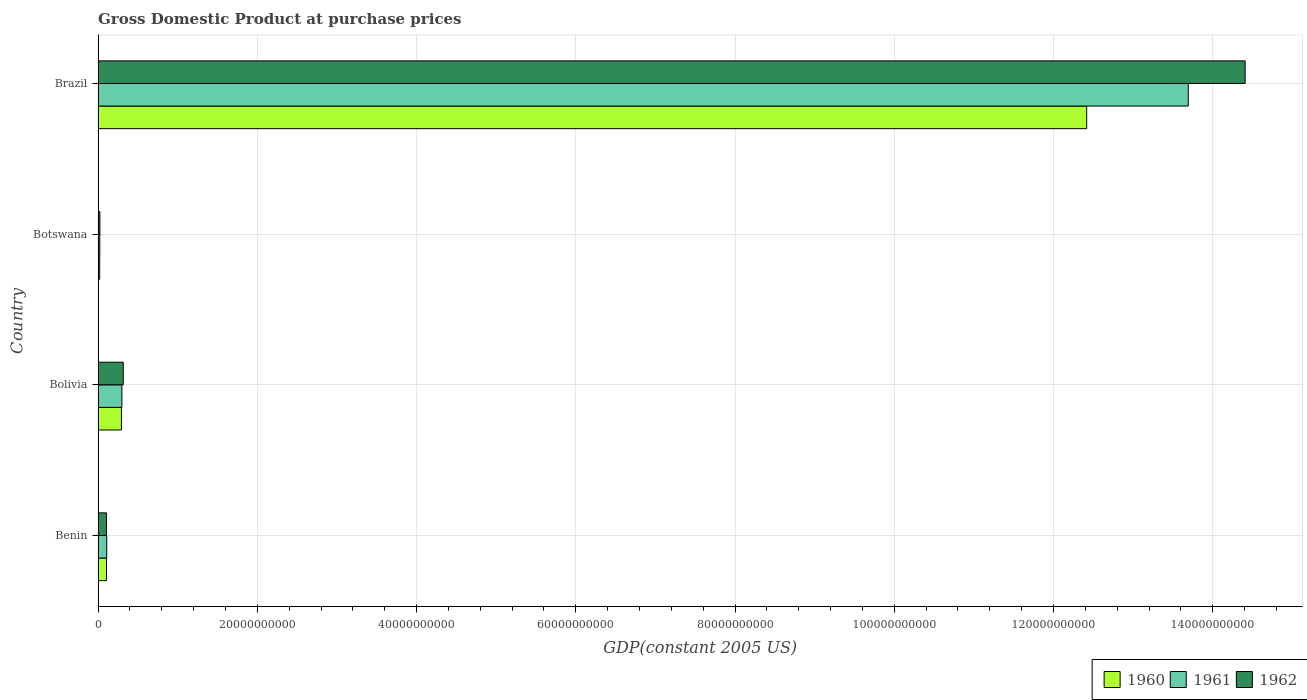How many different coloured bars are there?
Ensure brevity in your answer.  3. How many bars are there on the 1st tick from the top?
Keep it short and to the point. 3. How many bars are there on the 1st tick from the bottom?
Give a very brief answer. 3. What is the label of the 4th group of bars from the top?
Your response must be concise. Benin. What is the GDP at purchase prices in 1961 in Bolivia?
Provide a succinct answer. 2.99e+09. Across all countries, what is the maximum GDP at purchase prices in 1960?
Offer a terse response. 1.24e+11. Across all countries, what is the minimum GDP at purchase prices in 1961?
Your response must be concise. 2.12e+08. In which country was the GDP at purchase prices in 1962 maximum?
Ensure brevity in your answer.  Brazil. In which country was the GDP at purchase prices in 1961 minimum?
Offer a very short reply. Botswana. What is the total GDP at purchase prices in 1962 in the graph?
Offer a terse response. 1.48e+11. What is the difference between the GDP at purchase prices in 1960 in Bolivia and that in Botswana?
Give a very brief answer. 2.73e+09. What is the difference between the GDP at purchase prices in 1962 in Benin and the GDP at purchase prices in 1961 in Brazil?
Your answer should be compact. -1.36e+11. What is the average GDP at purchase prices in 1960 per country?
Provide a succinct answer. 3.21e+1. What is the difference between the GDP at purchase prices in 1960 and GDP at purchase prices in 1961 in Brazil?
Provide a succinct answer. -1.28e+1. In how many countries, is the GDP at purchase prices in 1960 greater than 80000000000 US$?
Provide a succinct answer. 1. What is the ratio of the GDP at purchase prices in 1960 in Benin to that in Botswana?
Your response must be concise. 5.29. Is the GDP at purchase prices in 1961 in Benin less than that in Botswana?
Ensure brevity in your answer.  No. Is the difference between the GDP at purchase prices in 1960 in Bolivia and Brazil greater than the difference between the GDP at purchase prices in 1961 in Bolivia and Brazil?
Keep it short and to the point. Yes. What is the difference between the highest and the second highest GDP at purchase prices in 1962?
Provide a short and direct response. 1.41e+11. What is the difference between the highest and the lowest GDP at purchase prices in 1960?
Offer a very short reply. 1.24e+11. Is it the case that in every country, the sum of the GDP at purchase prices in 1961 and GDP at purchase prices in 1962 is greater than the GDP at purchase prices in 1960?
Your response must be concise. Yes. What is the difference between two consecutive major ticks on the X-axis?
Your answer should be compact. 2.00e+1. Are the values on the major ticks of X-axis written in scientific E-notation?
Ensure brevity in your answer.  No. Does the graph contain grids?
Provide a short and direct response. Yes. How many legend labels are there?
Give a very brief answer. 3. What is the title of the graph?
Your answer should be compact. Gross Domestic Product at purchase prices. What is the label or title of the X-axis?
Provide a succinct answer. GDP(constant 2005 US). What is the label or title of the Y-axis?
Keep it short and to the point. Country. What is the GDP(constant 2005 US) of 1960 in Benin?
Offer a terse response. 1.05e+09. What is the GDP(constant 2005 US) of 1961 in Benin?
Offer a terse response. 1.09e+09. What is the GDP(constant 2005 US) of 1962 in Benin?
Keep it short and to the point. 1.05e+09. What is the GDP(constant 2005 US) of 1960 in Bolivia?
Offer a terse response. 2.93e+09. What is the GDP(constant 2005 US) of 1961 in Bolivia?
Your answer should be very brief. 2.99e+09. What is the GDP(constant 2005 US) in 1962 in Bolivia?
Give a very brief answer. 3.16e+09. What is the GDP(constant 2005 US) of 1960 in Botswana?
Give a very brief answer. 1.99e+08. What is the GDP(constant 2005 US) of 1961 in Botswana?
Your response must be concise. 2.12e+08. What is the GDP(constant 2005 US) in 1962 in Botswana?
Your response must be concise. 2.26e+08. What is the GDP(constant 2005 US) of 1960 in Brazil?
Offer a terse response. 1.24e+11. What is the GDP(constant 2005 US) of 1961 in Brazil?
Your response must be concise. 1.37e+11. What is the GDP(constant 2005 US) in 1962 in Brazil?
Offer a very short reply. 1.44e+11. Across all countries, what is the maximum GDP(constant 2005 US) in 1960?
Ensure brevity in your answer.  1.24e+11. Across all countries, what is the maximum GDP(constant 2005 US) of 1961?
Your response must be concise. 1.37e+11. Across all countries, what is the maximum GDP(constant 2005 US) in 1962?
Provide a short and direct response. 1.44e+11. Across all countries, what is the minimum GDP(constant 2005 US) of 1960?
Provide a succinct answer. 1.99e+08. Across all countries, what is the minimum GDP(constant 2005 US) in 1961?
Keep it short and to the point. 2.12e+08. Across all countries, what is the minimum GDP(constant 2005 US) of 1962?
Provide a short and direct response. 2.26e+08. What is the total GDP(constant 2005 US) in 1960 in the graph?
Ensure brevity in your answer.  1.28e+11. What is the total GDP(constant 2005 US) of 1961 in the graph?
Your answer should be compact. 1.41e+11. What is the total GDP(constant 2005 US) of 1962 in the graph?
Your answer should be very brief. 1.48e+11. What is the difference between the GDP(constant 2005 US) in 1960 in Benin and that in Bolivia?
Your answer should be very brief. -1.88e+09. What is the difference between the GDP(constant 2005 US) of 1961 in Benin and that in Bolivia?
Offer a very short reply. -1.91e+09. What is the difference between the GDP(constant 2005 US) in 1962 in Benin and that in Bolivia?
Offer a terse response. -2.11e+09. What is the difference between the GDP(constant 2005 US) in 1960 in Benin and that in Botswana?
Provide a succinct answer. 8.54e+08. What is the difference between the GDP(constant 2005 US) in 1961 in Benin and that in Botswana?
Offer a terse response. 8.74e+08. What is the difference between the GDP(constant 2005 US) in 1962 in Benin and that in Botswana?
Your answer should be very brief. 8.23e+08. What is the difference between the GDP(constant 2005 US) in 1960 in Benin and that in Brazil?
Your response must be concise. -1.23e+11. What is the difference between the GDP(constant 2005 US) of 1961 in Benin and that in Brazil?
Offer a very short reply. -1.36e+11. What is the difference between the GDP(constant 2005 US) in 1962 in Benin and that in Brazil?
Offer a very short reply. -1.43e+11. What is the difference between the GDP(constant 2005 US) in 1960 in Bolivia and that in Botswana?
Make the answer very short. 2.73e+09. What is the difference between the GDP(constant 2005 US) of 1961 in Bolivia and that in Botswana?
Ensure brevity in your answer.  2.78e+09. What is the difference between the GDP(constant 2005 US) of 1962 in Bolivia and that in Botswana?
Your response must be concise. 2.93e+09. What is the difference between the GDP(constant 2005 US) of 1960 in Bolivia and that in Brazil?
Offer a terse response. -1.21e+11. What is the difference between the GDP(constant 2005 US) of 1961 in Bolivia and that in Brazil?
Give a very brief answer. -1.34e+11. What is the difference between the GDP(constant 2005 US) in 1962 in Bolivia and that in Brazil?
Provide a short and direct response. -1.41e+11. What is the difference between the GDP(constant 2005 US) of 1960 in Botswana and that in Brazil?
Your response must be concise. -1.24e+11. What is the difference between the GDP(constant 2005 US) in 1961 in Botswana and that in Brazil?
Your response must be concise. -1.37e+11. What is the difference between the GDP(constant 2005 US) of 1962 in Botswana and that in Brazil?
Make the answer very short. -1.44e+11. What is the difference between the GDP(constant 2005 US) in 1960 in Benin and the GDP(constant 2005 US) in 1961 in Bolivia?
Offer a very short reply. -1.94e+09. What is the difference between the GDP(constant 2005 US) in 1960 in Benin and the GDP(constant 2005 US) in 1962 in Bolivia?
Your answer should be very brief. -2.11e+09. What is the difference between the GDP(constant 2005 US) of 1961 in Benin and the GDP(constant 2005 US) of 1962 in Bolivia?
Your answer should be compact. -2.07e+09. What is the difference between the GDP(constant 2005 US) of 1960 in Benin and the GDP(constant 2005 US) of 1961 in Botswana?
Your answer should be compact. 8.41e+08. What is the difference between the GDP(constant 2005 US) in 1960 in Benin and the GDP(constant 2005 US) in 1962 in Botswana?
Provide a short and direct response. 8.27e+08. What is the difference between the GDP(constant 2005 US) in 1961 in Benin and the GDP(constant 2005 US) in 1962 in Botswana?
Your response must be concise. 8.60e+08. What is the difference between the GDP(constant 2005 US) in 1960 in Benin and the GDP(constant 2005 US) in 1961 in Brazil?
Give a very brief answer. -1.36e+11. What is the difference between the GDP(constant 2005 US) in 1960 in Benin and the GDP(constant 2005 US) in 1962 in Brazil?
Your response must be concise. -1.43e+11. What is the difference between the GDP(constant 2005 US) of 1961 in Benin and the GDP(constant 2005 US) of 1962 in Brazil?
Offer a very short reply. -1.43e+11. What is the difference between the GDP(constant 2005 US) in 1960 in Bolivia and the GDP(constant 2005 US) in 1961 in Botswana?
Ensure brevity in your answer.  2.72e+09. What is the difference between the GDP(constant 2005 US) in 1960 in Bolivia and the GDP(constant 2005 US) in 1962 in Botswana?
Your answer should be very brief. 2.71e+09. What is the difference between the GDP(constant 2005 US) in 1961 in Bolivia and the GDP(constant 2005 US) in 1962 in Botswana?
Offer a terse response. 2.77e+09. What is the difference between the GDP(constant 2005 US) in 1960 in Bolivia and the GDP(constant 2005 US) in 1961 in Brazil?
Provide a succinct answer. -1.34e+11. What is the difference between the GDP(constant 2005 US) of 1960 in Bolivia and the GDP(constant 2005 US) of 1962 in Brazil?
Offer a very short reply. -1.41e+11. What is the difference between the GDP(constant 2005 US) of 1961 in Bolivia and the GDP(constant 2005 US) of 1962 in Brazil?
Your answer should be compact. -1.41e+11. What is the difference between the GDP(constant 2005 US) in 1960 in Botswana and the GDP(constant 2005 US) in 1961 in Brazil?
Your answer should be compact. -1.37e+11. What is the difference between the GDP(constant 2005 US) of 1960 in Botswana and the GDP(constant 2005 US) of 1962 in Brazil?
Your response must be concise. -1.44e+11. What is the difference between the GDP(constant 2005 US) of 1961 in Botswana and the GDP(constant 2005 US) of 1962 in Brazil?
Make the answer very short. -1.44e+11. What is the average GDP(constant 2005 US) of 1960 per country?
Offer a very short reply. 3.21e+1. What is the average GDP(constant 2005 US) in 1961 per country?
Offer a very short reply. 3.53e+1. What is the average GDP(constant 2005 US) in 1962 per country?
Provide a succinct answer. 3.71e+1. What is the difference between the GDP(constant 2005 US) of 1960 and GDP(constant 2005 US) of 1961 in Benin?
Your answer should be very brief. -3.31e+07. What is the difference between the GDP(constant 2005 US) in 1960 and GDP(constant 2005 US) in 1962 in Benin?
Your response must be concise. 4.14e+06. What is the difference between the GDP(constant 2005 US) of 1961 and GDP(constant 2005 US) of 1962 in Benin?
Provide a short and direct response. 3.72e+07. What is the difference between the GDP(constant 2005 US) of 1960 and GDP(constant 2005 US) of 1961 in Bolivia?
Provide a succinct answer. -6.10e+07. What is the difference between the GDP(constant 2005 US) of 1960 and GDP(constant 2005 US) of 1962 in Bolivia?
Give a very brief answer. -2.28e+08. What is the difference between the GDP(constant 2005 US) in 1961 and GDP(constant 2005 US) in 1962 in Bolivia?
Provide a short and direct response. -1.67e+08. What is the difference between the GDP(constant 2005 US) in 1960 and GDP(constant 2005 US) in 1961 in Botswana?
Provide a succinct answer. -1.26e+07. What is the difference between the GDP(constant 2005 US) in 1960 and GDP(constant 2005 US) in 1962 in Botswana?
Provide a short and direct response. -2.67e+07. What is the difference between the GDP(constant 2005 US) in 1961 and GDP(constant 2005 US) in 1962 in Botswana?
Your answer should be very brief. -1.41e+07. What is the difference between the GDP(constant 2005 US) of 1960 and GDP(constant 2005 US) of 1961 in Brazil?
Offer a terse response. -1.28e+1. What is the difference between the GDP(constant 2005 US) in 1960 and GDP(constant 2005 US) in 1962 in Brazil?
Your answer should be compact. -1.99e+1. What is the difference between the GDP(constant 2005 US) of 1961 and GDP(constant 2005 US) of 1962 in Brazil?
Offer a very short reply. -7.14e+09. What is the ratio of the GDP(constant 2005 US) in 1960 in Benin to that in Bolivia?
Offer a very short reply. 0.36. What is the ratio of the GDP(constant 2005 US) in 1961 in Benin to that in Bolivia?
Your answer should be very brief. 0.36. What is the ratio of the GDP(constant 2005 US) in 1962 in Benin to that in Bolivia?
Your answer should be very brief. 0.33. What is the ratio of the GDP(constant 2005 US) in 1960 in Benin to that in Botswana?
Your answer should be compact. 5.29. What is the ratio of the GDP(constant 2005 US) in 1961 in Benin to that in Botswana?
Provide a short and direct response. 5.13. What is the ratio of the GDP(constant 2005 US) in 1962 in Benin to that in Botswana?
Make the answer very short. 4.65. What is the ratio of the GDP(constant 2005 US) in 1960 in Benin to that in Brazil?
Give a very brief answer. 0.01. What is the ratio of the GDP(constant 2005 US) of 1961 in Benin to that in Brazil?
Offer a terse response. 0.01. What is the ratio of the GDP(constant 2005 US) in 1962 in Benin to that in Brazil?
Your answer should be compact. 0.01. What is the ratio of the GDP(constant 2005 US) in 1960 in Bolivia to that in Botswana?
Offer a terse response. 14.73. What is the ratio of the GDP(constant 2005 US) of 1961 in Bolivia to that in Botswana?
Provide a succinct answer. 14.14. What is the ratio of the GDP(constant 2005 US) in 1962 in Bolivia to that in Botswana?
Offer a terse response. 14. What is the ratio of the GDP(constant 2005 US) of 1960 in Bolivia to that in Brazil?
Keep it short and to the point. 0.02. What is the ratio of the GDP(constant 2005 US) in 1961 in Bolivia to that in Brazil?
Your answer should be compact. 0.02. What is the ratio of the GDP(constant 2005 US) in 1962 in Bolivia to that in Brazil?
Offer a terse response. 0.02. What is the ratio of the GDP(constant 2005 US) in 1960 in Botswana to that in Brazil?
Offer a terse response. 0. What is the ratio of the GDP(constant 2005 US) in 1961 in Botswana to that in Brazil?
Give a very brief answer. 0. What is the ratio of the GDP(constant 2005 US) of 1962 in Botswana to that in Brazil?
Your response must be concise. 0. What is the difference between the highest and the second highest GDP(constant 2005 US) of 1960?
Provide a succinct answer. 1.21e+11. What is the difference between the highest and the second highest GDP(constant 2005 US) in 1961?
Ensure brevity in your answer.  1.34e+11. What is the difference between the highest and the second highest GDP(constant 2005 US) of 1962?
Make the answer very short. 1.41e+11. What is the difference between the highest and the lowest GDP(constant 2005 US) of 1960?
Offer a terse response. 1.24e+11. What is the difference between the highest and the lowest GDP(constant 2005 US) of 1961?
Your answer should be compact. 1.37e+11. What is the difference between the highest and the lowest GDP(constant 2005 US) of 1962?
Your answer should be very brief. 1.44e+11. 